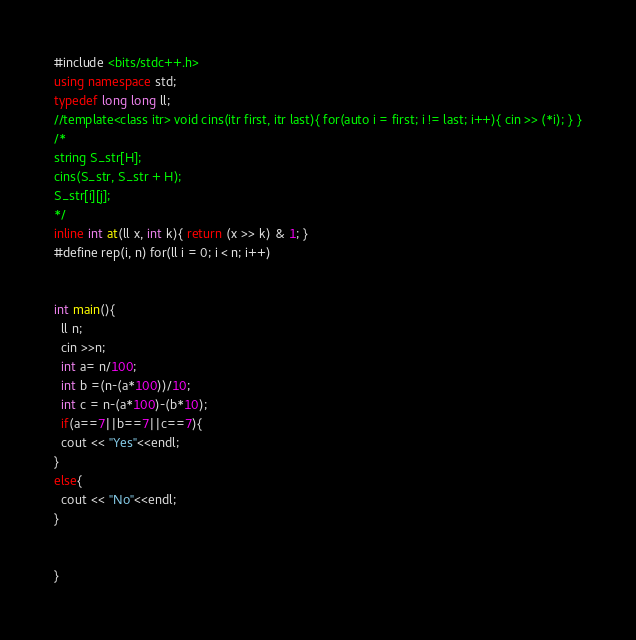Convert code to text. <code><loc_0><loc_0><loc_500><loc_500><_C++_>#include <bits/stdc++.h>
using namespace std;
typedef long long ll;
//template<class itr> void cins(itr first, itr last){ for(auto i = first; i != last; i++){ cin >> (*i); } }
/*
string S_str[H];
cins(S_str, S_str + H);
S_str[i][j];
*/
inline int at(ll x, int k){ return (x >> k) & 1; }
#define rep(i, n) for(ll i = 0; i < n; i++)


int main(){
  ll n;
  cin >>n;
  int a= n/100;
  int b =(n-(a*100))/10;
  int c = n-(a*100)-(b*10);
  if(a==7||b==7||c==7){
  cout << "Yes"<<endl;
}
else{
  cout << "No"<<endl;
}


}
</code> 